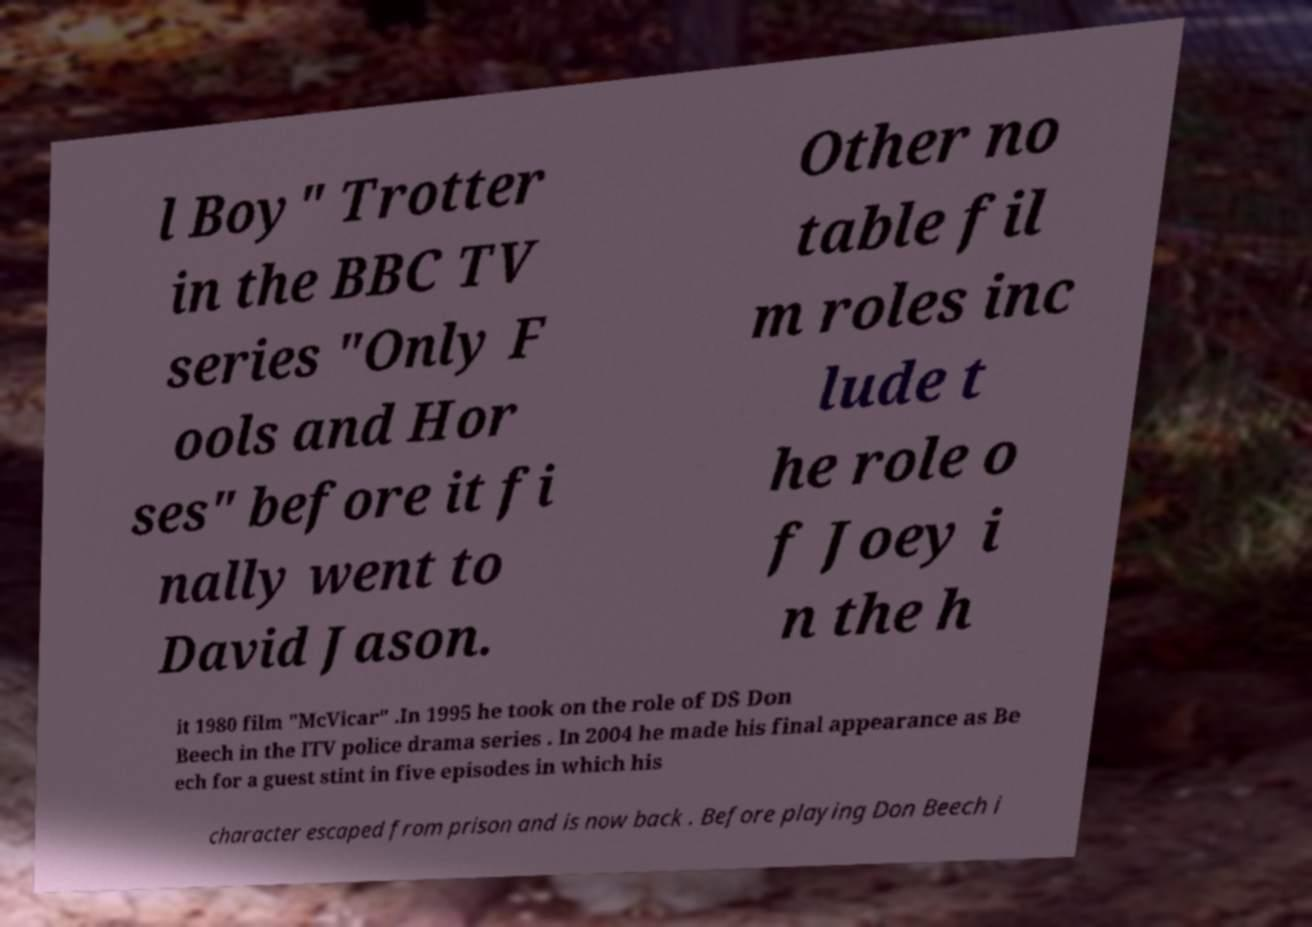Please identify and transcribe the text found in this image. l Boy" Trotter in the BBC TV series "Only F ools and Hor ses" before it fi nally went to David Jason. Other no table fil m roles inc lude t he role o f Joey i n the h it 1980 film "McVicar" .In 1995 he took on the role of DS Don Beech in the ITV police drama series . In 2004 he made his final appearance as Be ech for a guest stint in five episodes in which his character escaped from prison and is now back . Before playing Don Beech i 